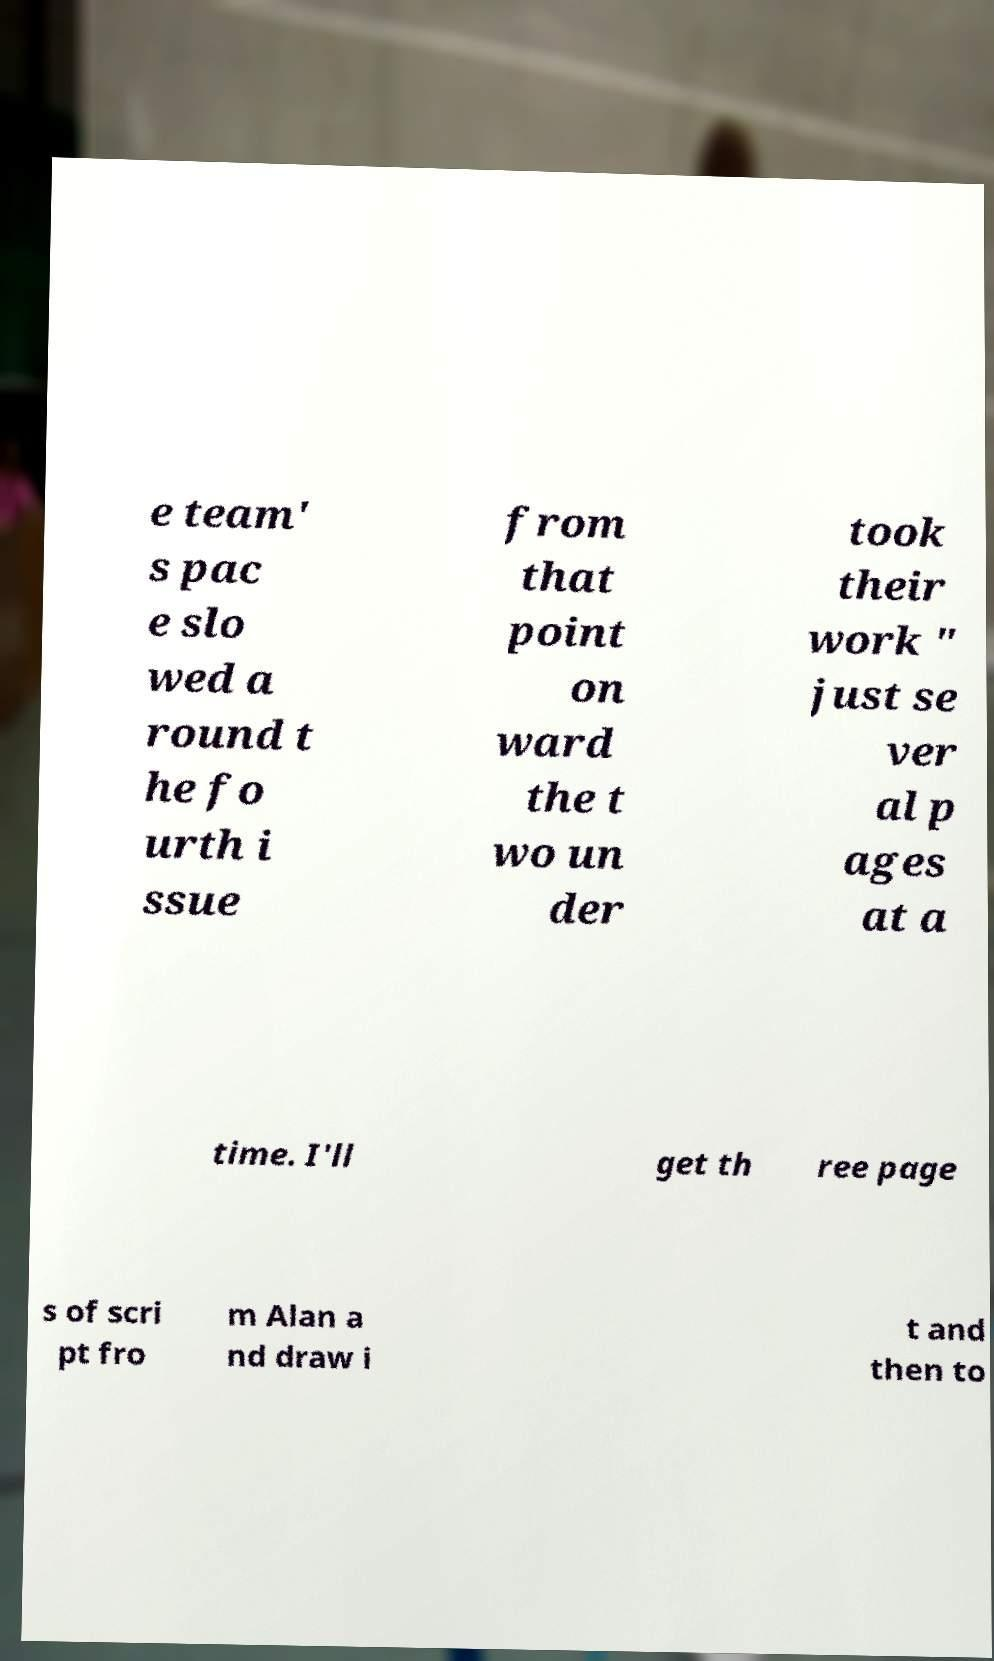Could you extract and type out the text from this image? e team' s pac e slo wed a round t he fo urth i ssue from that point on ward the t wo un der took their work " just se ver al p ages at a time. I'll get th ree page s of scri pt fro m Alan a nd draw i t and then to 